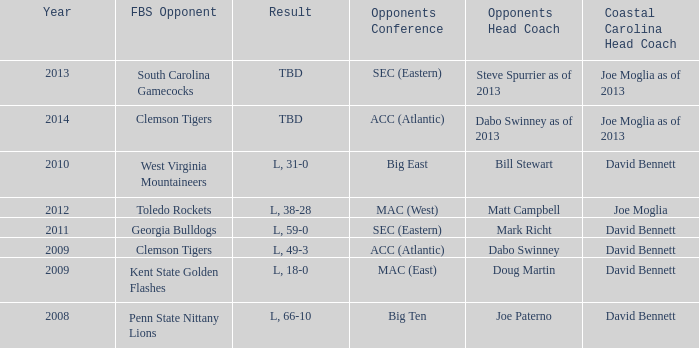Who was the coastal Carolina head coach in 2013? Joe Moglia as of 2013. 